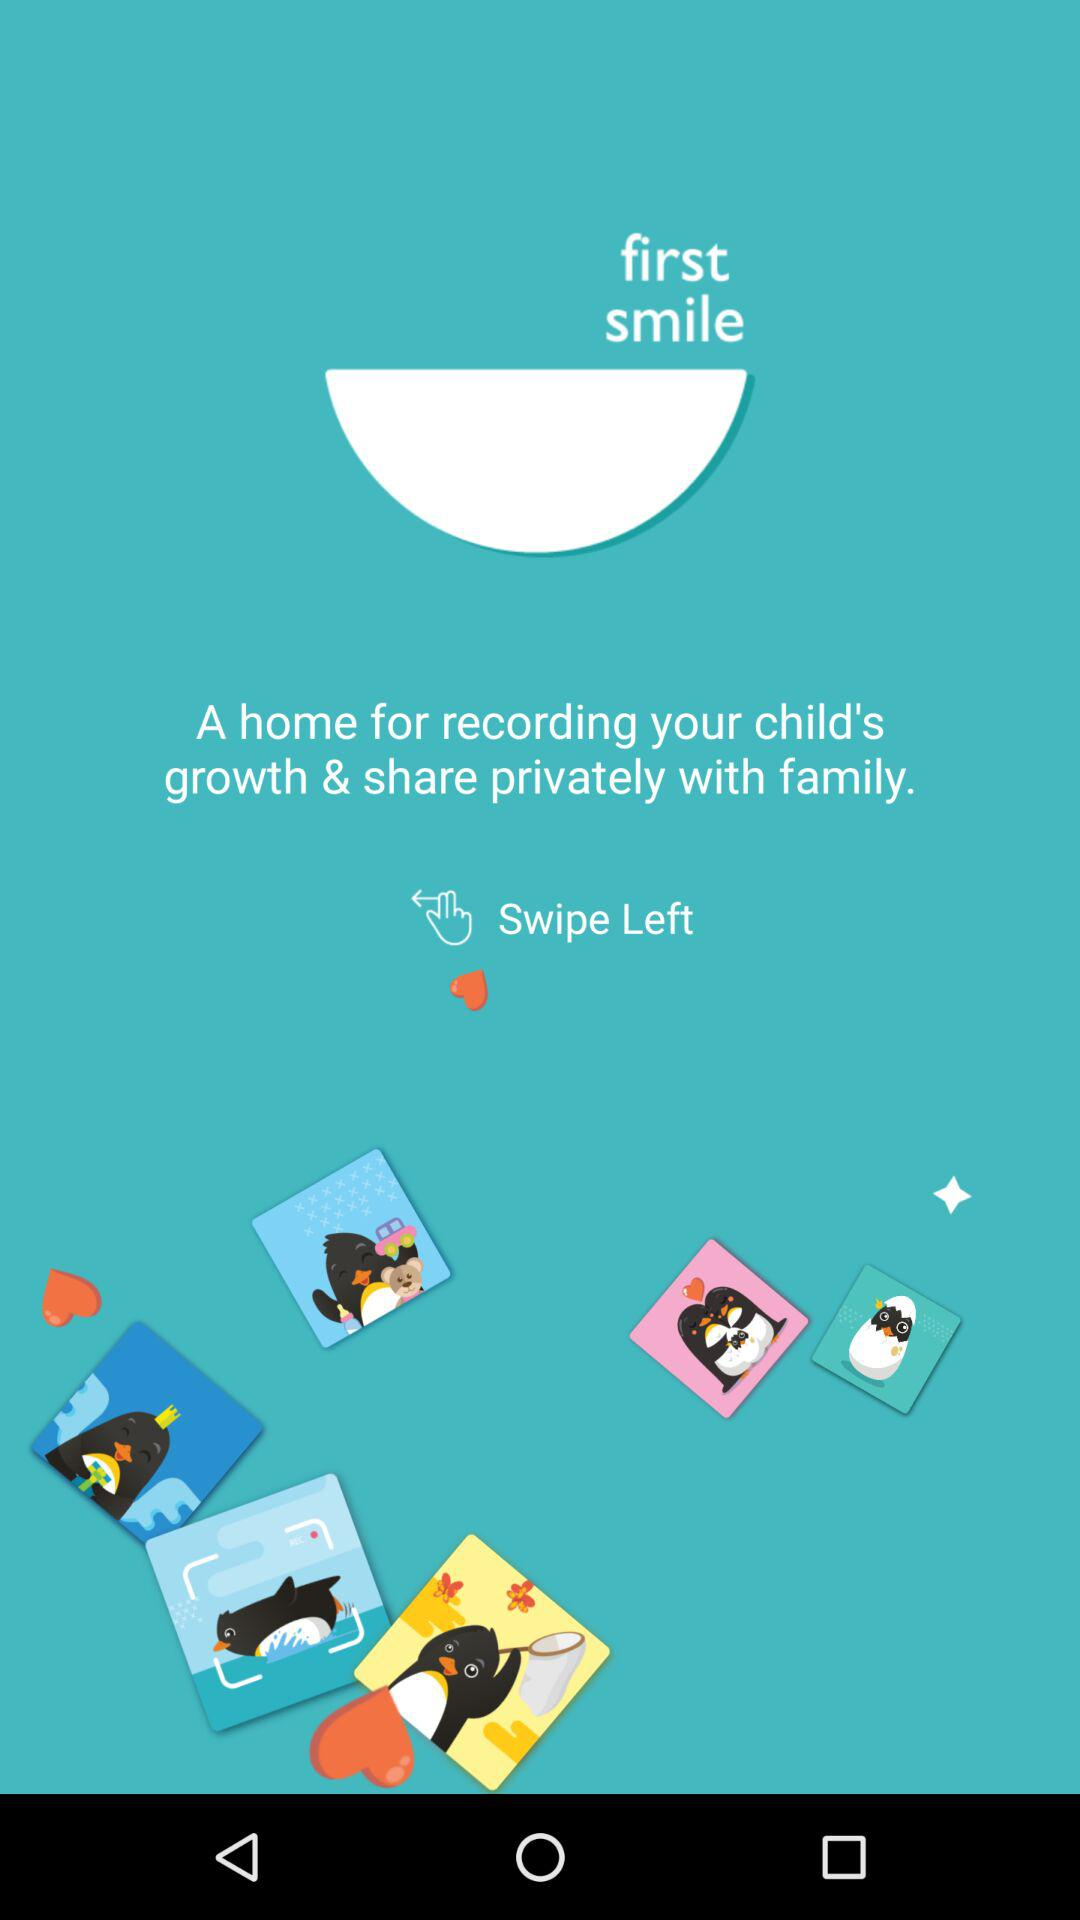How many more penguins are there than hearts on the screen?
Answer the question using a single word or phrase. 3 